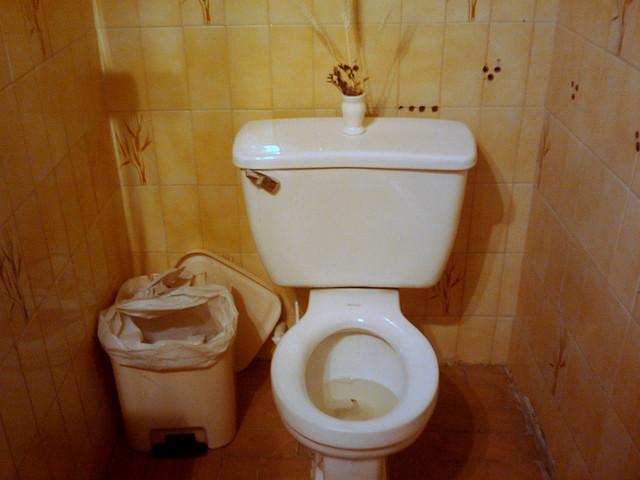Does the toilet contain feces?
Answer briefly. No. The bathroom is clean or not?
Be succinct. No. Is the trash can open?
Give a very brief answer. Yes. What is the yellow stuff in the toilet?
Keep it brief. Urine. 